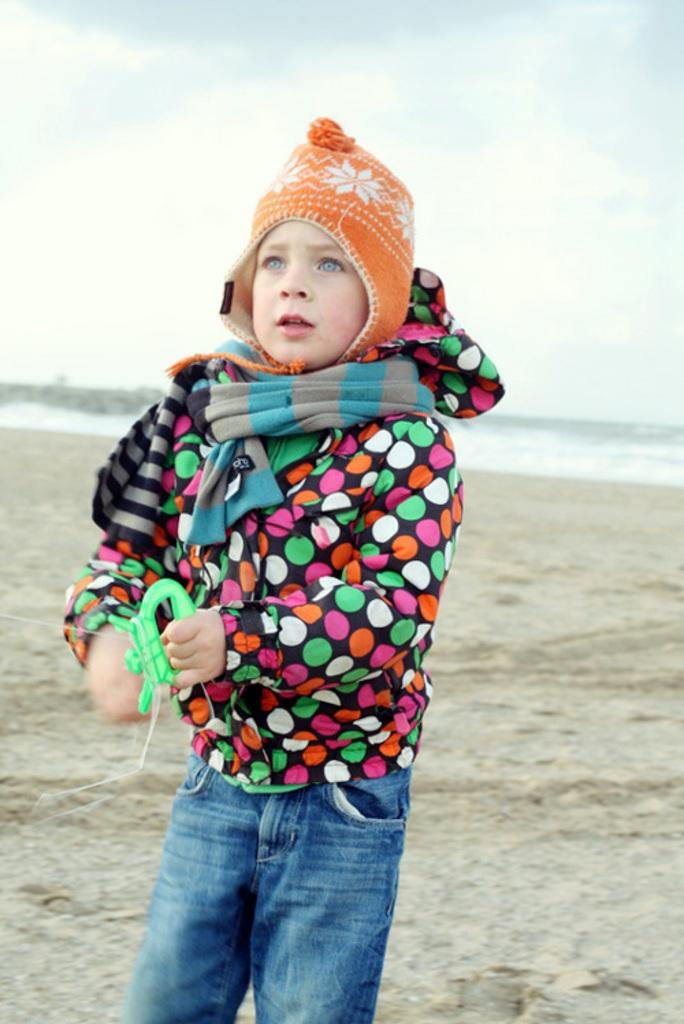Who is in the image? There is a boy in the image. What is the boy wearing on his head? The boy is wearing a cap. Where is the boy standing? The boy is standing on the ground. What can be seen in the background of the image? The sky is visible in the background of the image. What is present in the sky? Clouds are present in the sky. What type of stove can be seen in the image? There is no stove present in the image. What color are the boy's teeth in the image? The image does not show the boy's teeth, so we cannot determine their color. 